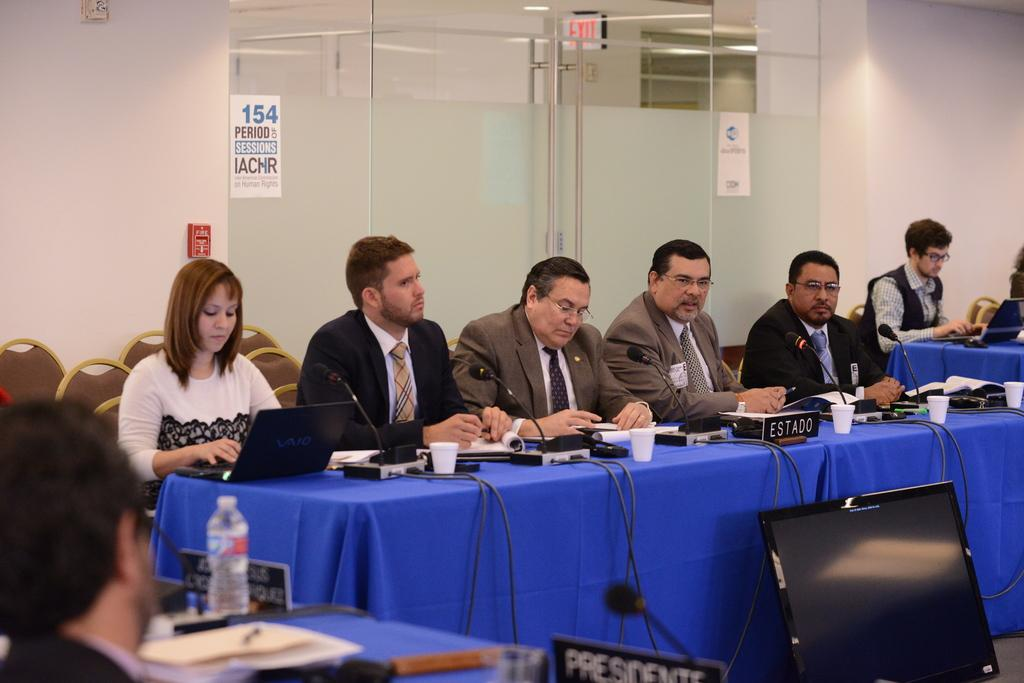<image>
Relay a brief, clear account of the picture shown. A conference is occurring in a room with a sign on the door that has number 154. 